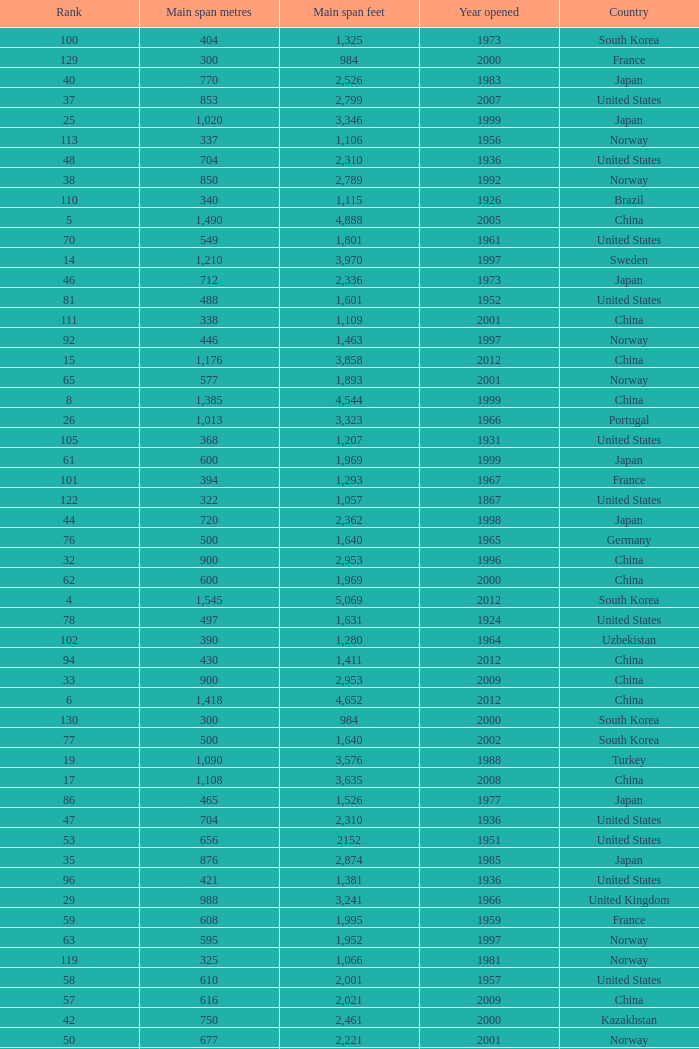What is the main span in feet from a year of 2009 or more recent with a rank less than 94 and 1,310 main span metres? 4298.0. 